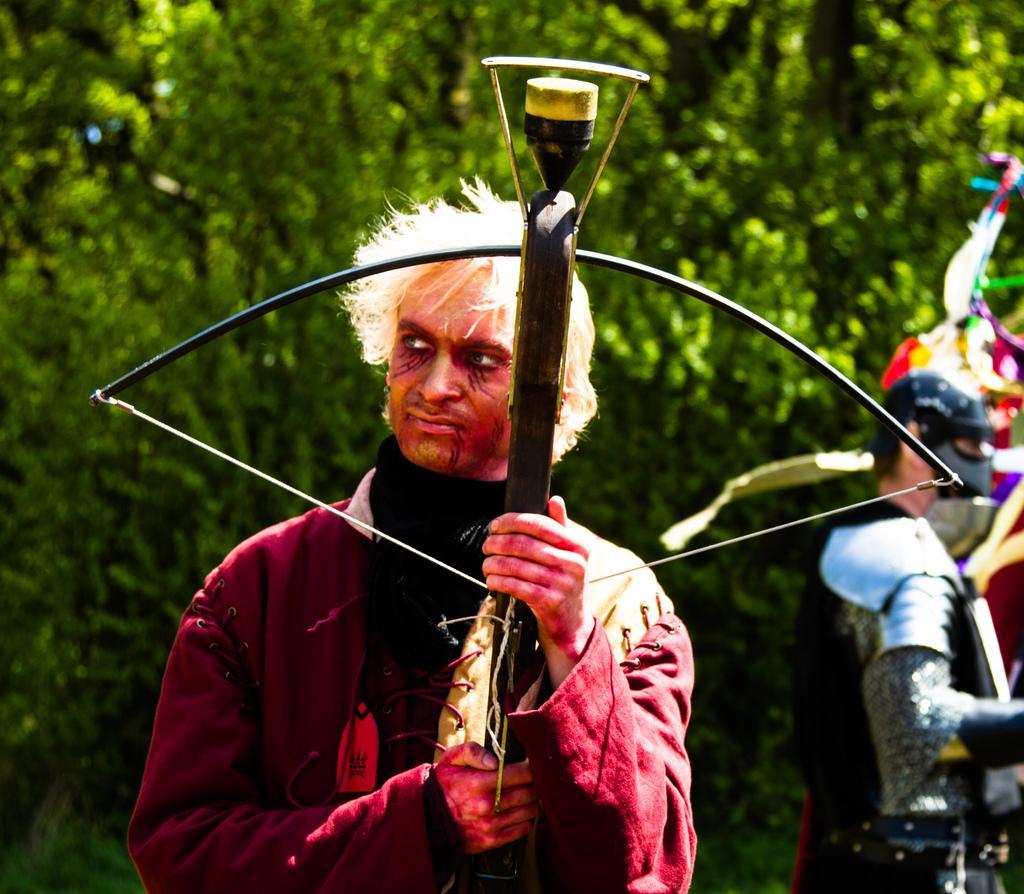Can you describe this image briefly? In this picture I can see there is a man standing and he is wearing a costume, he is wearing a maroon coat and holding a bow in his hand. There is another person standing in the backdrop and there are few trees and the backdrop is blurred. 